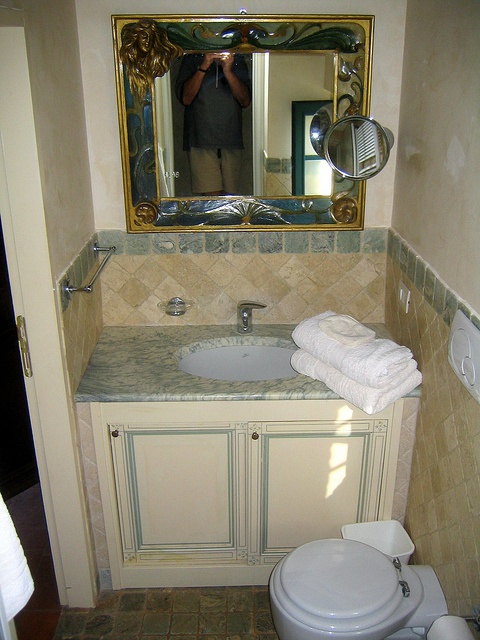Describe the objects in this image and their specific colors. I can see sink in darkgreen, gray, and darkgray tones, toilet in darkgreen, darkgray, and gray tones, and people in darkgreen, black, and brown tones in this image. 